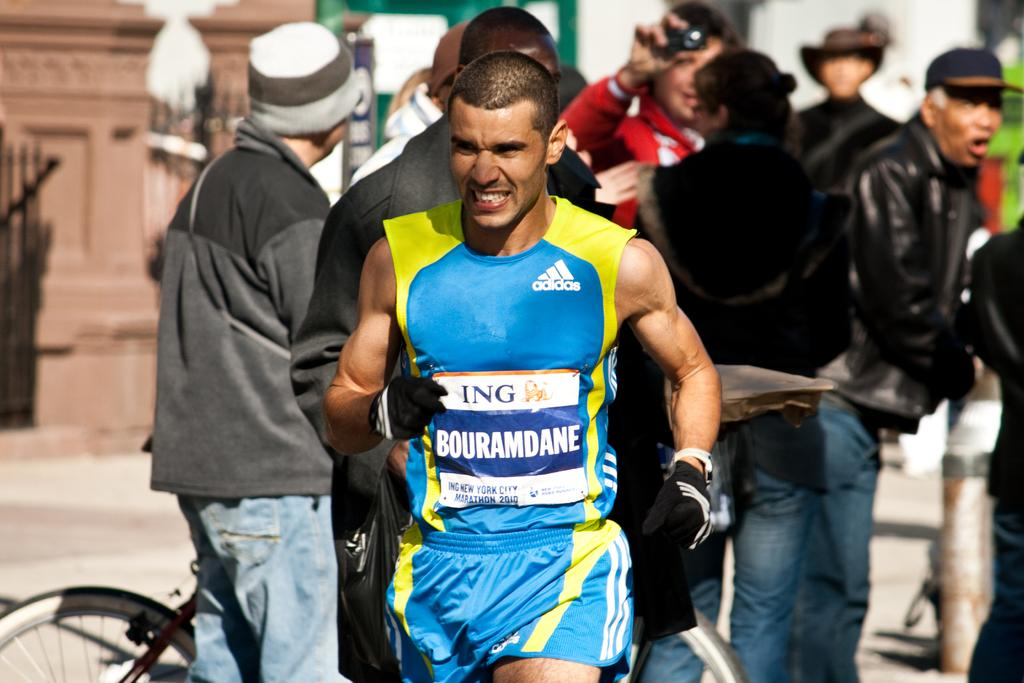<image>
Provide a brief description of the given image. A runner wearing a blue and yellow Adidas shirt passes by a bicycle. 